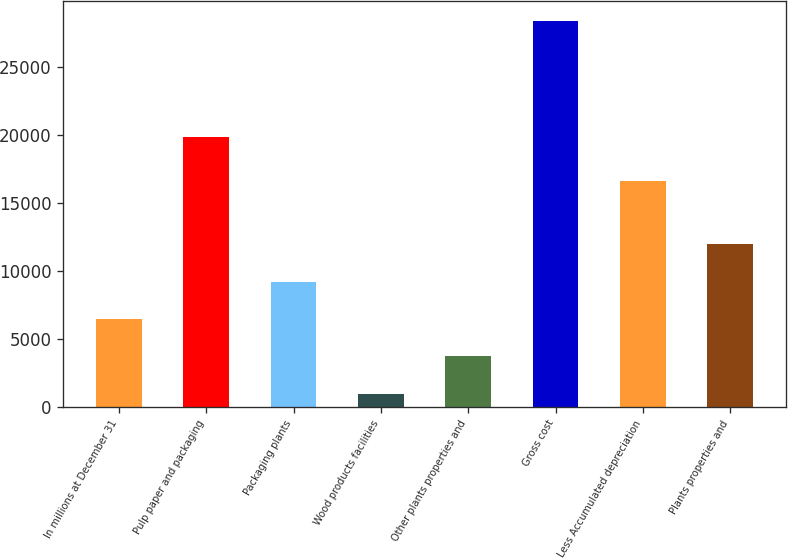Convert chart to OTSL. <chart><loc_0><loc_0><loc_500><loc_500><bar_chart><fcel>In millions at December 31<fcel>Pulp paper and packaging<fcel>Packaging plants<fcel>Wood products facilities<fcel>Other plants properties and<fcel>Gross cost<fcel>Less Accumulated depreciation<fcel>Plants properties and<nl><fcel>6465.2<fcel>19865<fcel>9208.8<fcel>978<fcel>3721.6<fcel>28414<fcel>16613<fcel>11952.4<nl></chart> 